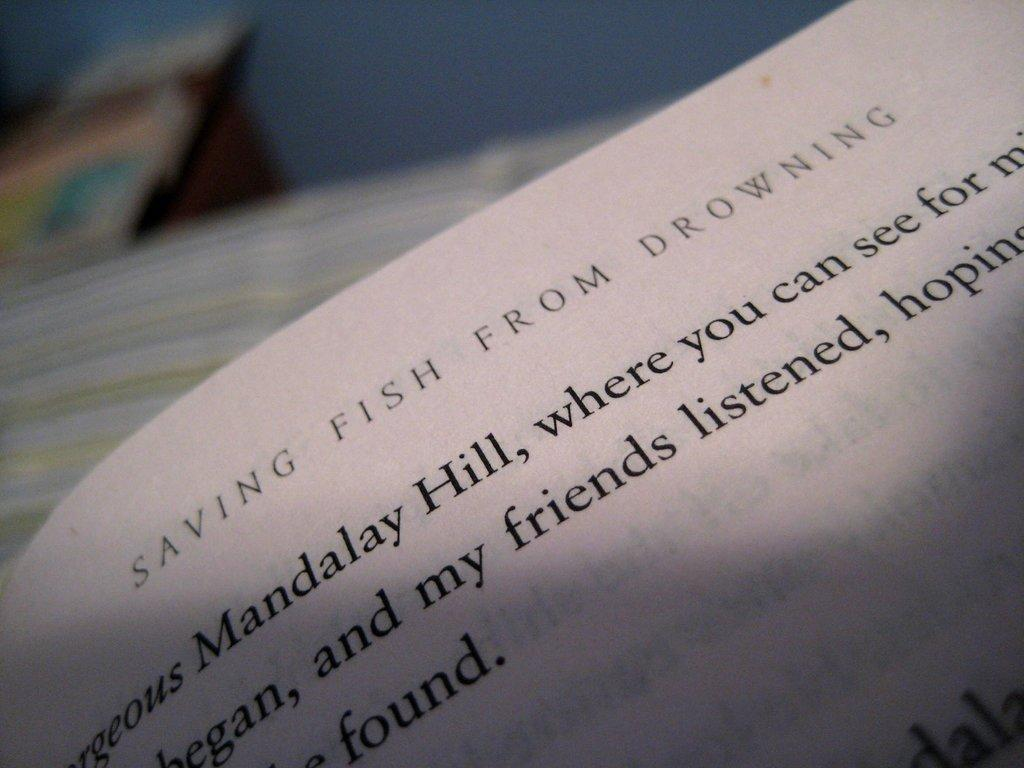What is the main subject in the foreground of the image? There is a paper in the foreground of the image. What type of flight is depicted in the image? There is no flight depicted in the image; it only features a paper in the foreground. What is the relation between the paper and the air in the image? There is no mention of air in the image, and the paper is not interacting with any air in a way that would suggest a relation. 